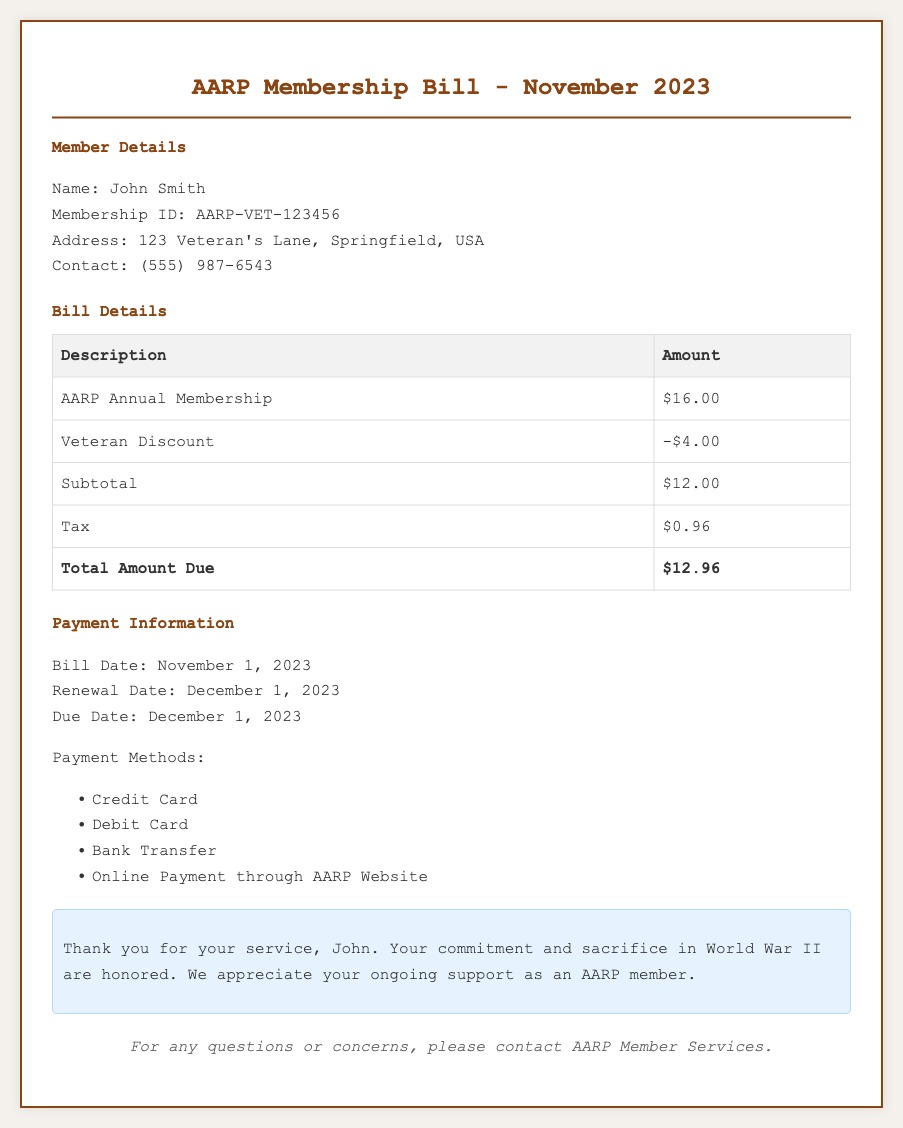What is the total amount due? The total amount due is mentioned in the bill, summing up all charges and discounts.
Answer: $12.96 What is the membership ID? The membership ID is a unique identifier for John Smith's account in AARP.
Answer: AARP-VET-123456 What is the renewal date? The renewal date is specified in the payment information section of the bill.
Answer: December 1, 2023 What veteran discount was applied? The veteran discount is the amount subtracted from the annual membership fee for veterans.
Answer: -$4.00 When was the bill date? The bill date is the date on which the bill was issued.
Answer: November 1, 2023 What is the subtotal before tax? The subtotal is the total amount before adding tax in the bill details.
Answer: $12.00 What are the payment methods listed? The payment methods offered are described in the payment information section of the document.
Answer: Credit Card, Debit Card, Bank Transfer, Online Payment through AARP Website Who is the member? The member's name is indicated at the beginning of the document.
Answer: John Smith What is the tax amount? The tax amount is mentioned in the bill details, reflecting the tax on the subtotal.
Answer: $0.96 